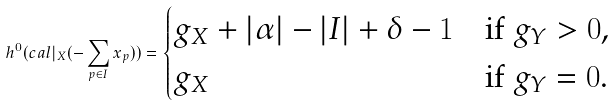<formula> <loc_0><loc_0><loc_500><loc_500>h ^ { 0 } ( \L c a l | _ { X } ( - \sum _ { p \in I } x _ { p } ) ) = \begin{cases} g _ { X } + | \alpha | - | I | + \delta - 1 & \text {if $g_{Y}>0$,} \\ g _ { X } & \text {if $g_{Y}=0$.} \end{cases}</formula> 